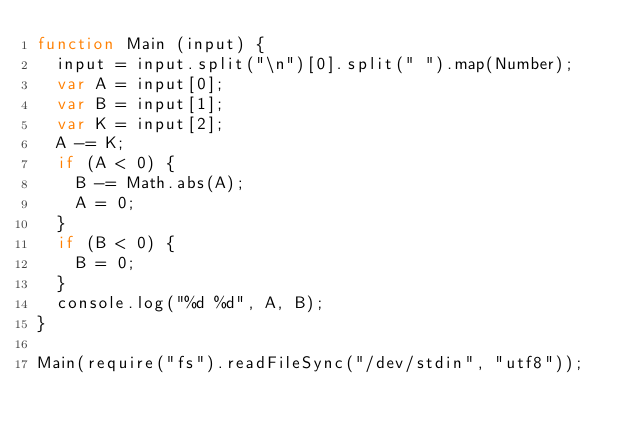Convert code to text. <code><loc_0><loc_0><loc_500><loc_500><_JavaScript_>function Main (input) {
  input = input.split("\n")[0].split(" ").map(Number);
  var A = input[0];
  var B = input[1];
  var K = input[2];
  A -= K;
  if (A < 0) {
    B -= Math.abs(A);
    A = 0;
  }
  if (B < 0) {
    B = 0;
  }
  console.log("%d %d", A, B);
}

Main(require("fs").readFileSync("/dev/stdin", "utf8"));</code> 